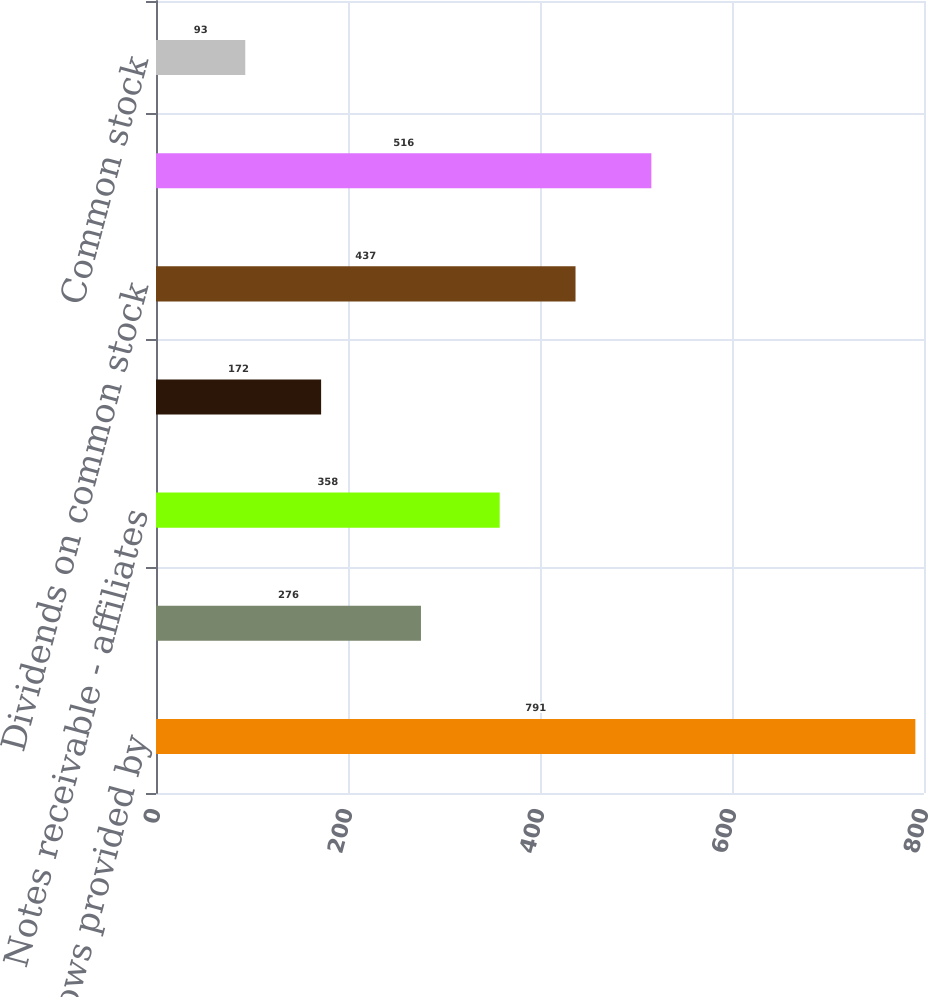<chart> <loc_0><loc_0><loc_500><loc_500><bar_chart><fcel>Net cash flows provided by<fcel>Money pool advances net<fcel>Notes receivable - affiliates<fcel>Investments in subsidiaries<fcel>Dividends on common stock<fcel>Short-term debt and credit<fcel>Common stock<nl><fcel>791<fcel>276<fcel>358<fcel>172<fcel>437<fcel>516<fcel>93<nl></chart> 